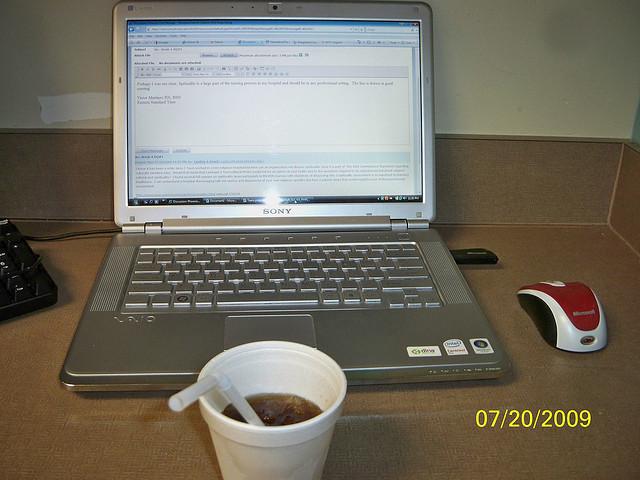How many mugs are on the table?
Answer briefly. 1. Does the drink have ice in it?
Be succinct. Yes. Is there a pen in this picture?
Answer briefly. No. What ad is on the mouse pad?
Write a very short answer. None. Is the mouse wireless?
Concise answer only. Yes. What is the drink?
Quick response, please. Soda. What is the cup made out of?
Give a very brief answer. Styrofoam. What is this person drinking?
Write a very short answer. Soda. 